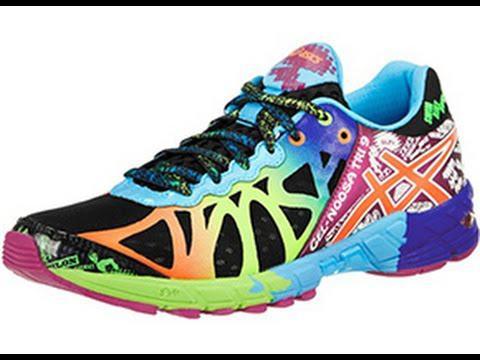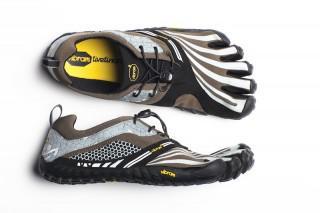The first image is the image on the left, the second image is the image on the right. For the images shown, is this caption "One image shows only one pair of black shoes with white and yellow trim." true? Answer yes or no. Yes. 